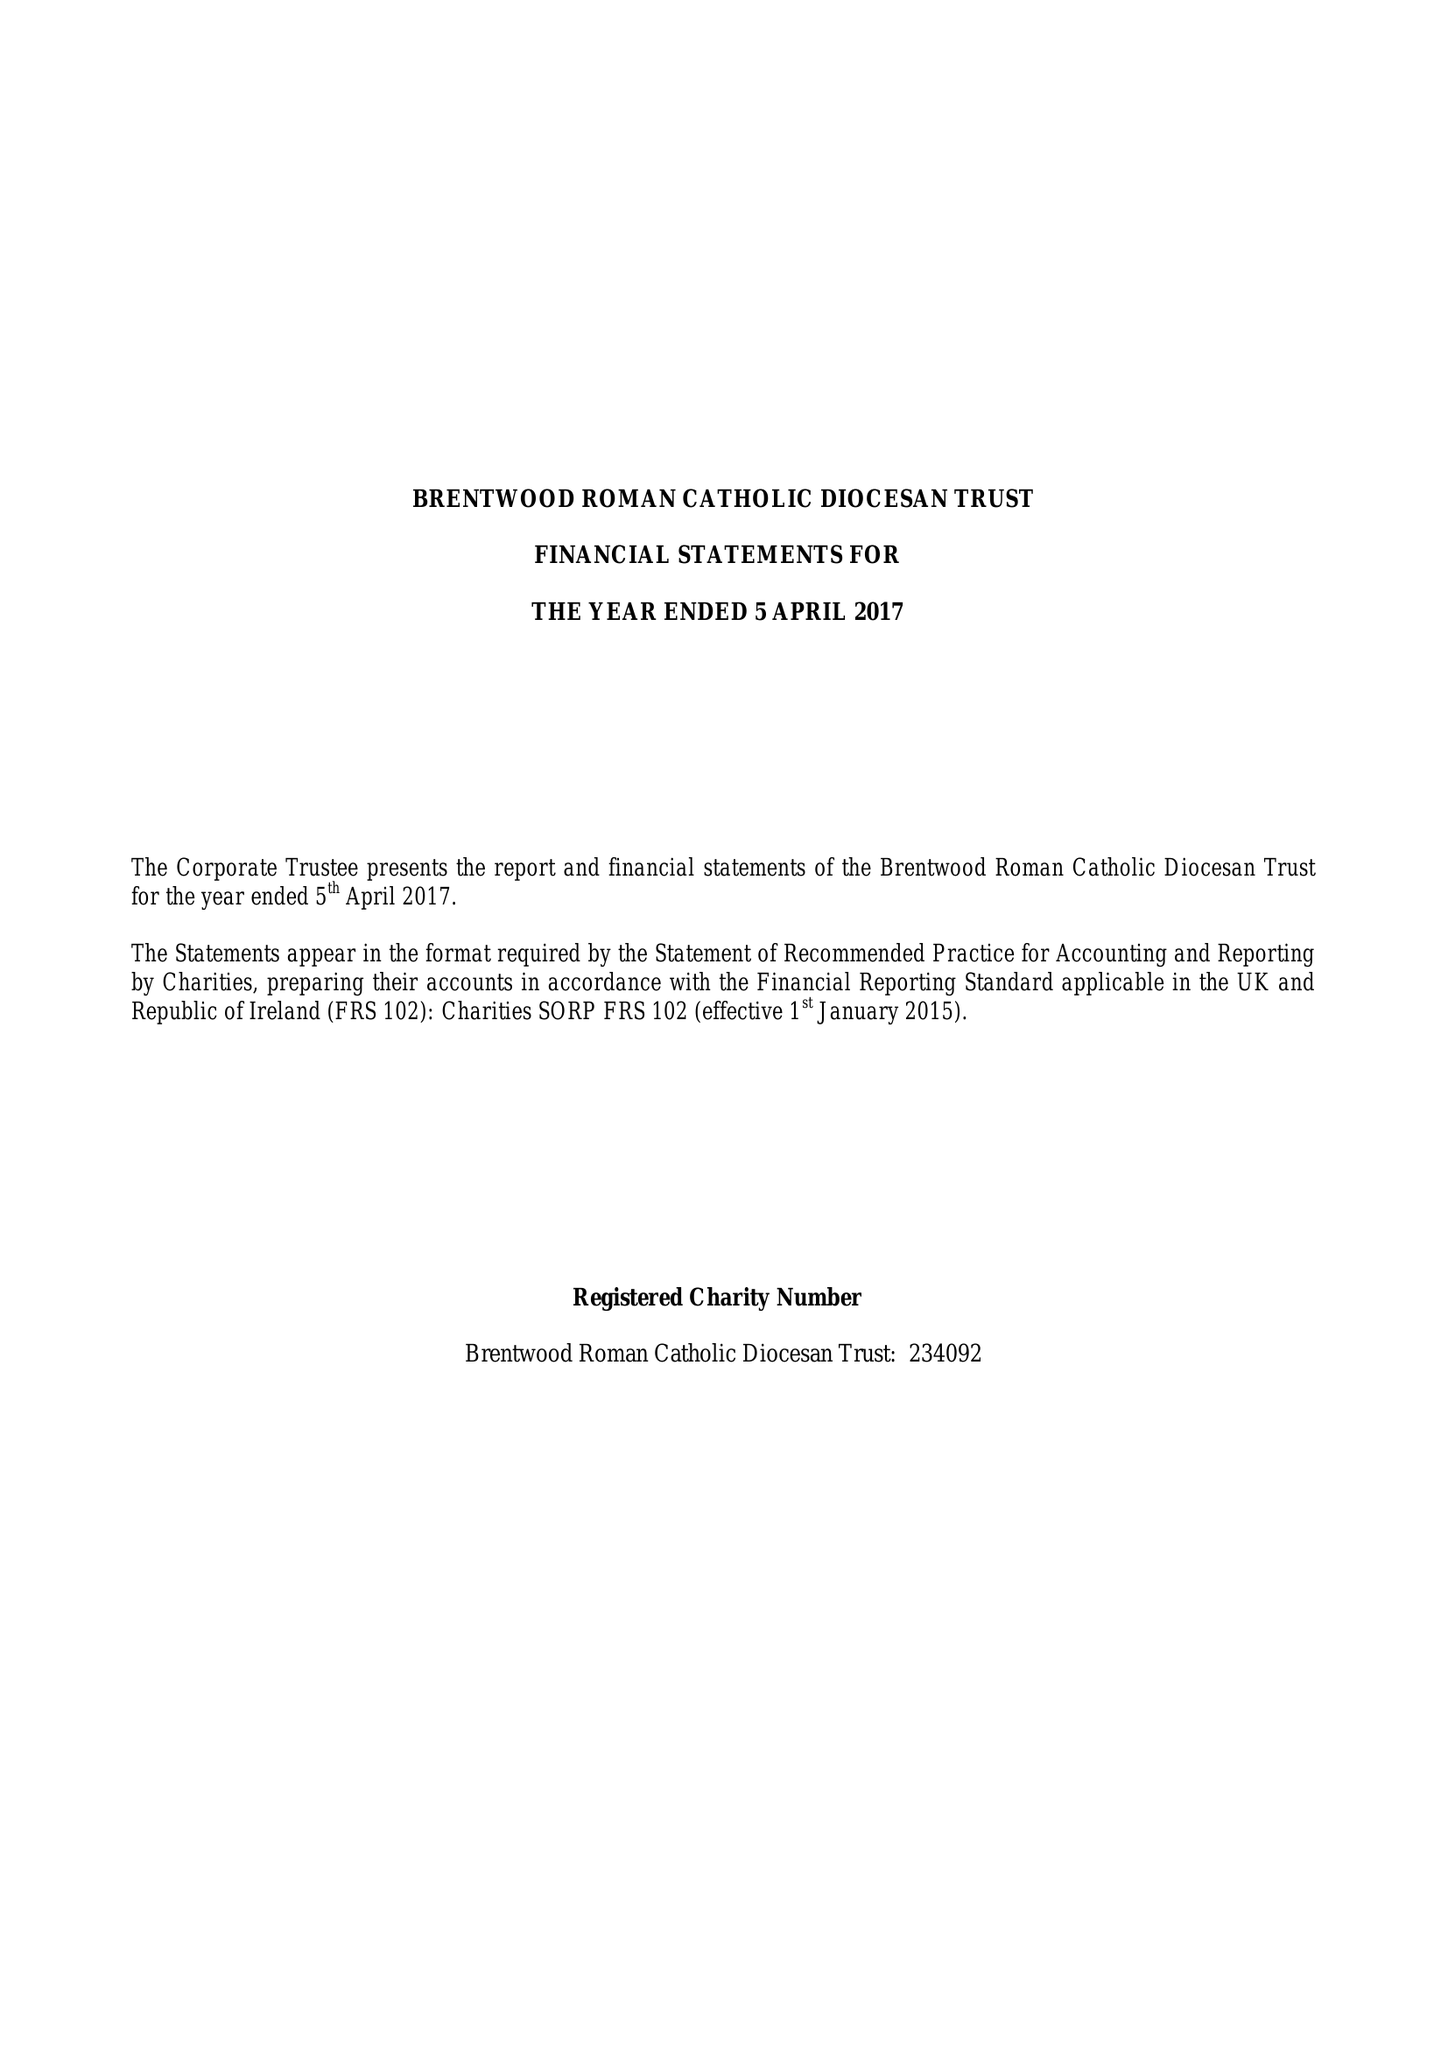What is the value for the address__post_town?
Answer the question using a single word or phrase. BRENTWOOD 